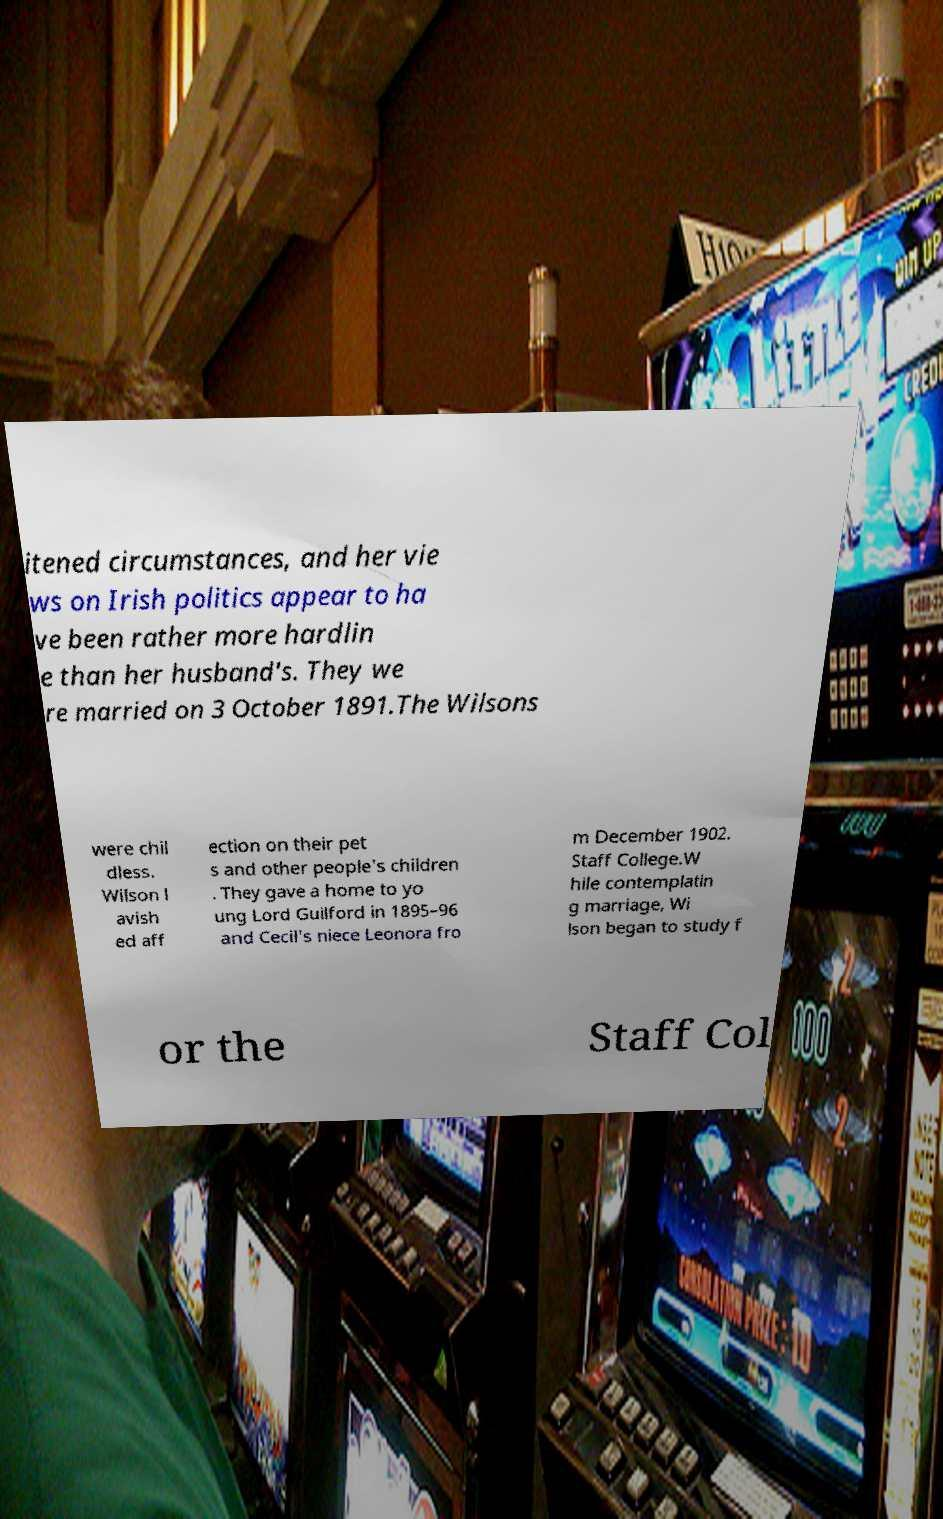Can you read and provide the text displayed in the image?This photo seems to have some interesting text. Can you extract and type it out for me? itened circumstances, and her vie ws on Irish politics appear to ha ve been rather more hardlin e than her husband's. They we re married on 3 October 1891.The Wilsons were chil dless. Wilson l avish ed aff ection on their pet s and other people's children . They gave a home to yo ung Lord Guilford in 1895–96 and Cecil's niece Leonora fro m December 1902. Staff College.W hile contemplatin g marriage, Wi lson began to study f or the Staff Col 